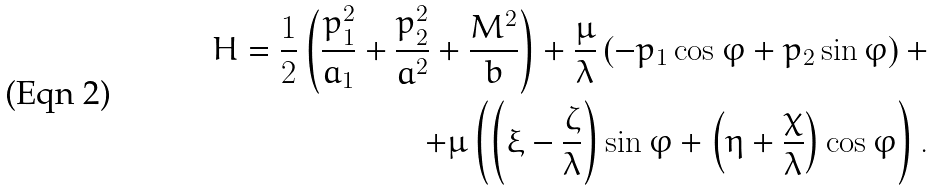Convert formula to latex. <formula><loc_0><loc_0><loc_500><loc_500>H = \frac { 1 } { 2 } \left ( \frac { p _ { 1 } ^ { 2 } } { a _ { 1 } } + \frac { p _ { 2 } ^ { 2 } } { a ^ { 2 } } + \frac { M ^ { 2 } } { b } \right ) + \frac { \mu } { \lambda } \left ( - p _ { 1 } \cos \varphi + p _ { 2 } \sin \varphi \right ) + \\ + \mu \left ( \left ( \xi - \frac { \zeta } { \lambda } \right ) \sin \varphi + \left ( \eta + \frac { \chi } { \lambda } \right ) \cos \varphi \right ) .</formula> 